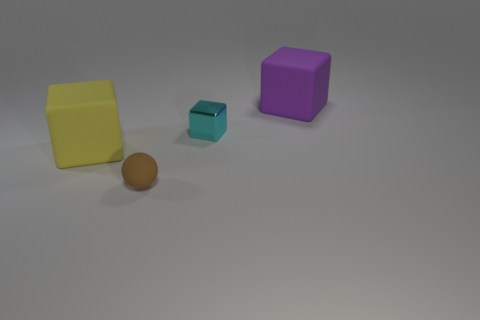Subtract all large blocks. How many blocks are left? 1 Add 4 small cyan blocks. How many objects exist? 8 Subtract all purple blocks. How many blocks are left? 2 Subtract all blocks. How many objects are left? 1 Subtract 1 cubes. How many cubes are left? 2 Add 2 large yellow rubber cubes. How many large yellow rubber cubes exist? 3 Subtract 0 blue cubes. How many objects are left? 4 Subtract all blue blocks. Subtract all green spheres. How many blocks are left? 3 Subtract all large gray rubber things. Subtract all tiny cyan things. How many objects are left? 3 Add 2 rubber spheres. How many rubber spheres are left? 3 